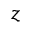<formula> <loc_0><loc_0><loc_500><loc_500>z</formula> 